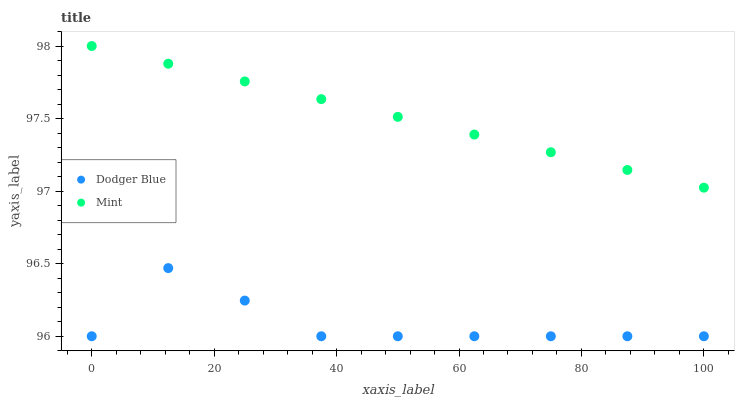Does Dodger Blue have the minimum area under the curve?
Answer yes or no. Yes. Does Mint have the maximum area under the curve?
Answer yes or no. Yes. Does Dodger Blue have the maximum area under the curve?
Answer yes or no. No. Is Mint the smoothest?
Answer yes or no. Yes. Is Dodger Blue the roughest?
Answer yes or no. Yes. Is Dodger Blue the smoothest?
Answer yes or no. No. Does Dodger Blue have the lowest value?
Answer yes or no. Yes. Does Mint have the highest value?
Answer yes or no. Yes. Does Dodger Blue have the highest value?
Answer yes or no. No. Is Dodger Blue less than Mint?
Answer yes or no. Yes. Is Mint greater than Dodger Blue?
Answer yes or no. Yes. Does Dodger Blue intersect Mint?
Answer yes or no. No. 